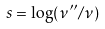Convert formula to latex. <formula><loc_0><loc_0><loc_500><loc_500>s = \log ( \nu ^ { \prime \prime } / \nu )</formula> 